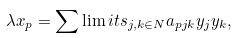<formula> <loc_0><loc_0><loc_500><loc_500>\lambda x _ { p } = \sum \lim i t s _ { j , k \in N } a _ { p j k } y _ { j } y _ { k } ,</formula> 